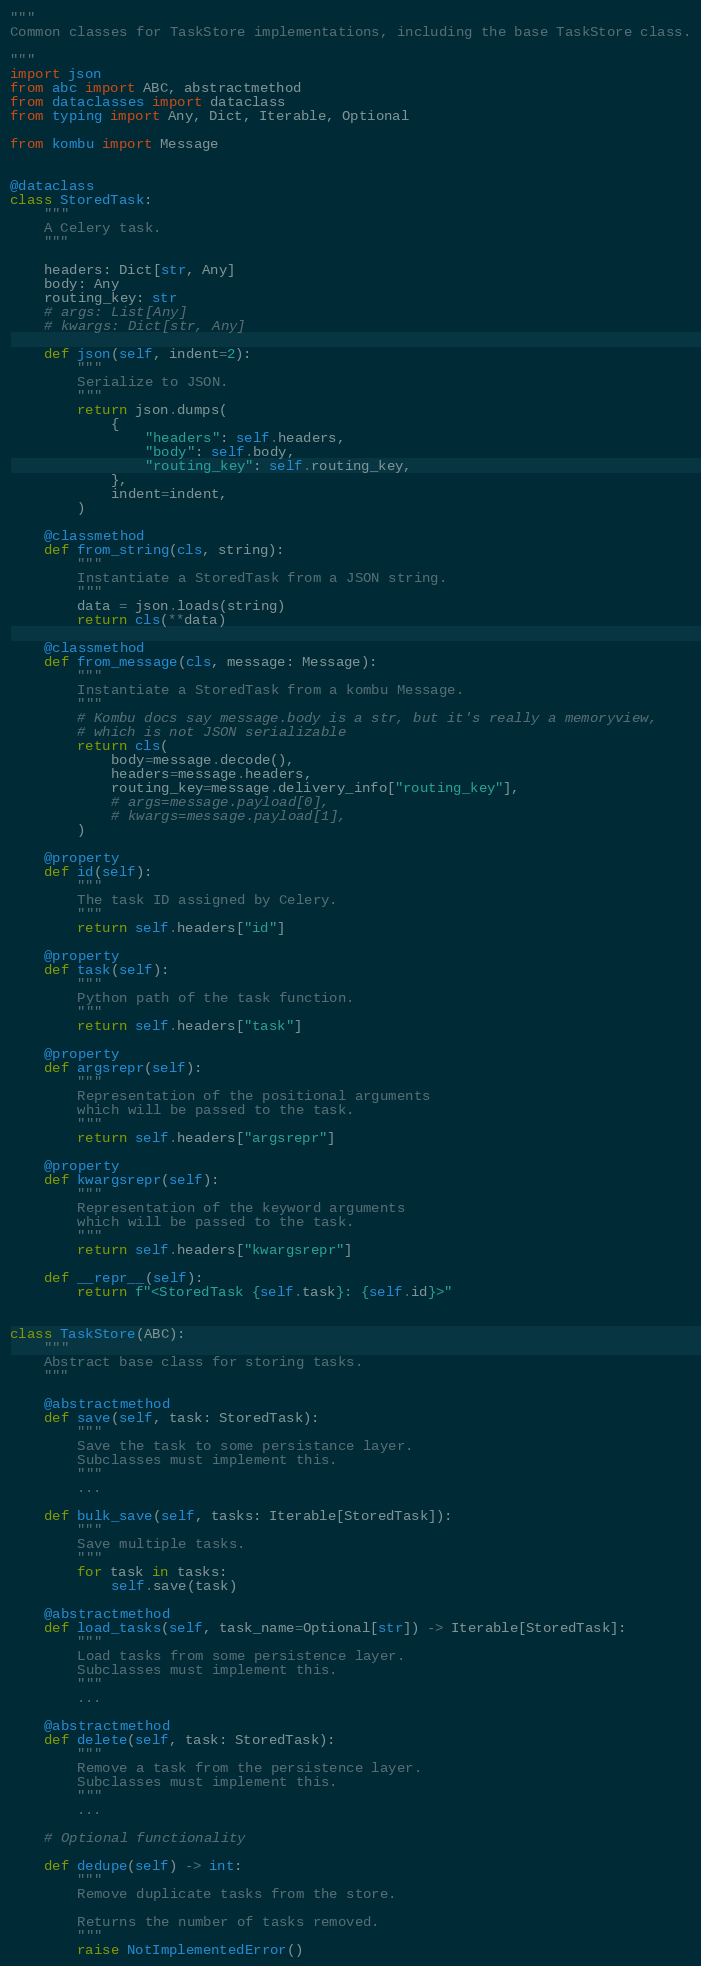Convert code to text. <code><loc_0><loc_0><loc_500><loc_500><_Python_>"""
Common classes for TaskStore implementations, including the base TaskStore class.

"""
import json
from abc import ABC, abstractmethod
from dataclasses import dataclass
from typing import Any, Dict, Iterable, Optional

from kombu import Message


@dataclass
class StoredTask:
    """
    A Celery task.
    """

    headers: Dict[str, Any]
    body: Any
    routing_key: str
    # args: List[Any]
    # kwargs: Dict[str, Any]

    def json(self, indent=2):
        """
        Serialize to JSON.
        """
        return json.dumps(
            {
                "headers": self.headers,
                "body": self.body,
                "routing_key": self.routing_key,
            },
            indent=indent,
        )

    @classmethod
    def from_string(cls, string):
        """
        Instantiate a StoredTask from a JSON string.
        """
        data = json.loads(string)
        return cls(**data)

    @classmethod
    def from_message(cls, message: Message):
        """
        Instantiate a StoredTask from a kombu Message.
        """
        # Kombu docs say message.body is a str, but it's really a memoryview,
        # which is not JSON serializable
        return cls(
            body=message.decode(),
            headers=message.headers,
            routing_key=message.delivery_info["routing_key"],
            # args=message.payload[0],
            # kwargs=message.payload[1],
        )

    @property
    def id(self):
        """
        The task ID assigned by Celery.
        """
        return self.headers["id"]

    @property
    def task(self):
        """
        Python path of the task function.
        """
        return self.headers["task"]

    @property
    def argsrepr(self):
        """
        Representation of the positional arguments
        which will be passed to the task.
        """
        return self.headers["argsrepr"]

    @property
    def kwargsrepr(self):
        """
        Representation of the keyword arguments
        which will be passed to the task.
        """
        return self.headers["kwargsrepr"]

    def __repr__(self):
        return f"<StoredTask {self.task}: {self.id}>"


class TaskStore(ABC):
    """
    Abstract base class for storing tasks.
    """

    @abstractmethod
    def save(self, task: StoredTask):
        """
        Save the task to some persistance layer.
        Subclasses must implement this.
        """
        ...

    def bulk_save(self, tasks: Iterable[StoredTask]):
        """
        Save multiple tasks.
        """
        for task in tasks:
            self.save(task)

    @abstractmethod
    def load_tasks(self, task_name=Optional[str]) -> Iterable[StoredTask]:
        """
        Load tasks from some persistence layer.
        Subclasses must implement this.
        """
        ...

    @abstractmethod
    def delete(self, task: StoredTask):
        """
        Remove a task from the persistence layer.
        Subclasses must implement this.
        """
        ...

    # Optional functionality

    def dedupe(self) -> int:
        """
        Remove duplicate tasks from the store.

        Returns the number of tasks removed.
        """
        raise NotImplementedError()
</code> 